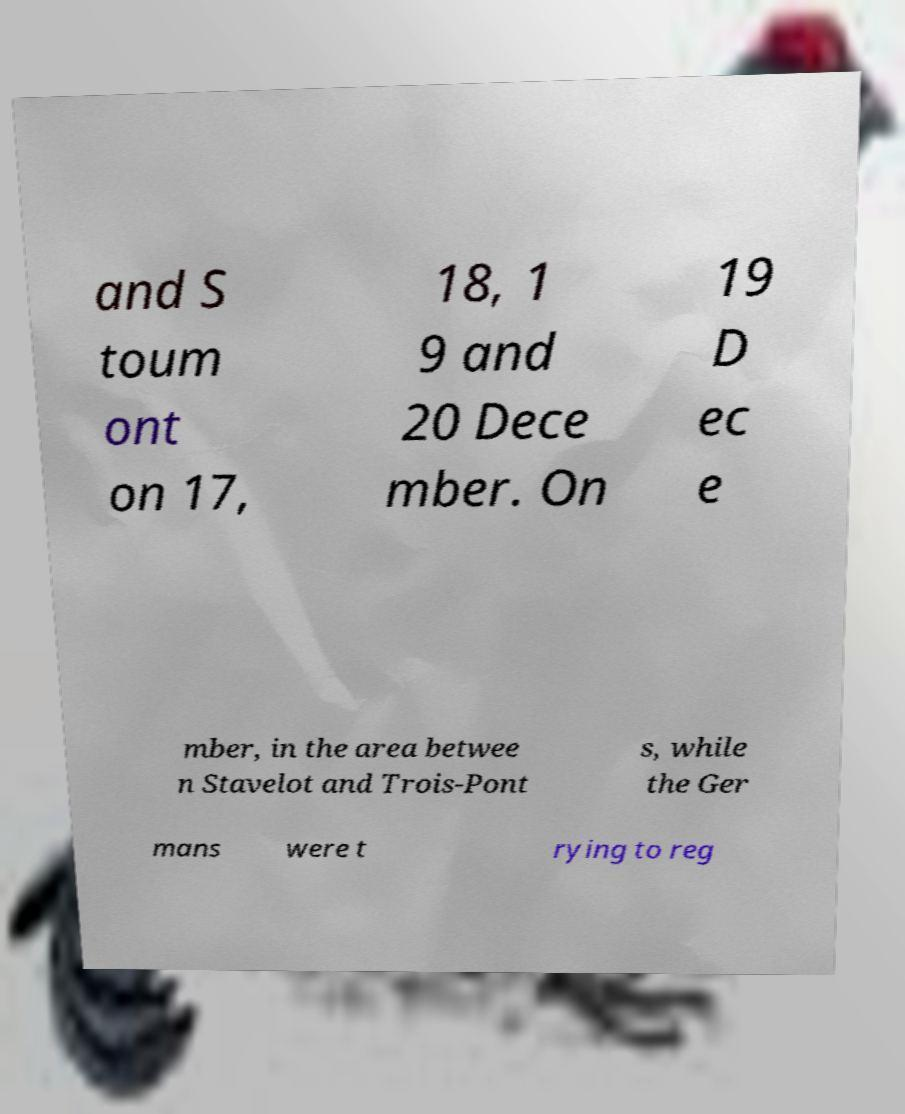What messages or text are displayed in this image? I need them in a readable, typed format. and S toum ont on 17, 18, 1 9 and 20 Dece mber. On 19 D ec e mber, in the area betwee n Stavelot and Trois-Pont s, while the Ger mans were t rying to reg 